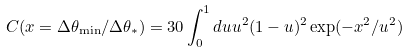Convert formula to latex. <formula><loc_0><loc_0><loc_500><loc_500>C ( x = \Delta \theta _ { \min } / \Delta \theta _ { * } ) = 3 0 \int _ { 0 } ^ { 1 } d u u ^ { 2 } ( 1 - u ) ^ { 2 } \exp ( - x ^ { 2 } / u ^ { 2 } )</formula> 